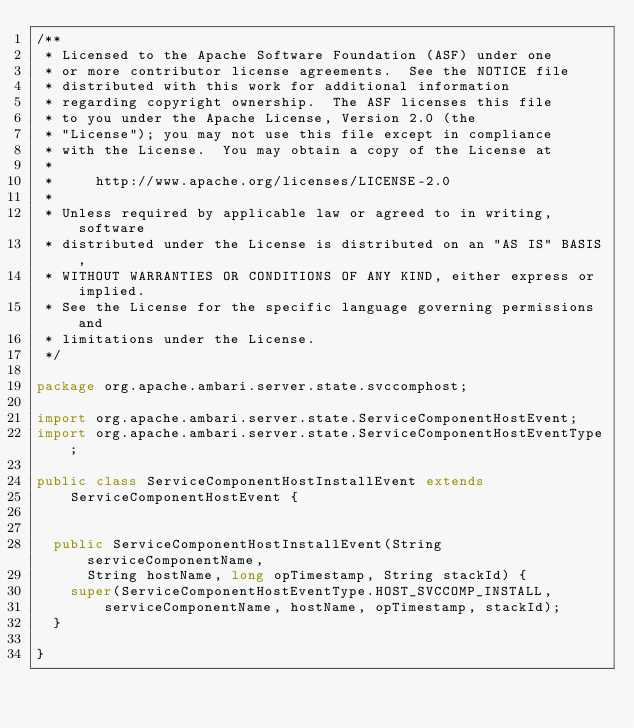<code> <loc_0><loc_0><loc_500><loc_500><_Java_>/**
 * Licensed to the Apache Software Foundation (ASF) under one
 * or more contributor license agreements.  See the NOTICE file
 * distributed with this work for additional information
 * regarding copyright ownership.  The ASF licenses this file
 * to you under the Apache License, Version 2.0 (the
 * "License"); you may not use this file except in compliance
 * with the License.  You may obtain a copy of the License at
 *
 *     http://www.apache.org/licenses/LICENSE-2.0
 *
 * Unless required by applicable law or agreed to in writing, software
 * distributed under the License is distributed on an "AS IS" BASIS,
 * WITHOUT WARRANTIES OR CONDITIONS OF ANY KIND, either express or implied.
 * See the License for the specific language governing permissions and
 * limitations under the License.
 */

package org.apache.ambari.server.state.svccomphost;

import org.apache.ambari.server.state.ServiceComponentHostEvent;
import org.apache.ambari.server.state.ServiceComponentHostEventType;

public class ServiceComponentHostInstallEvent extends
    ServiceComponentHostEvent {


  public ServiceComponentHostInstallEvent(String serviceComponentName,
      String hostName, long opTimestamp, String stackId) {
    super(ServiceComponentHostEventType.HOST_SVCCOMP_INSTALL,
        serviceComponentName, hostName, opTimestamp, stackId);
  }

}
</code> 